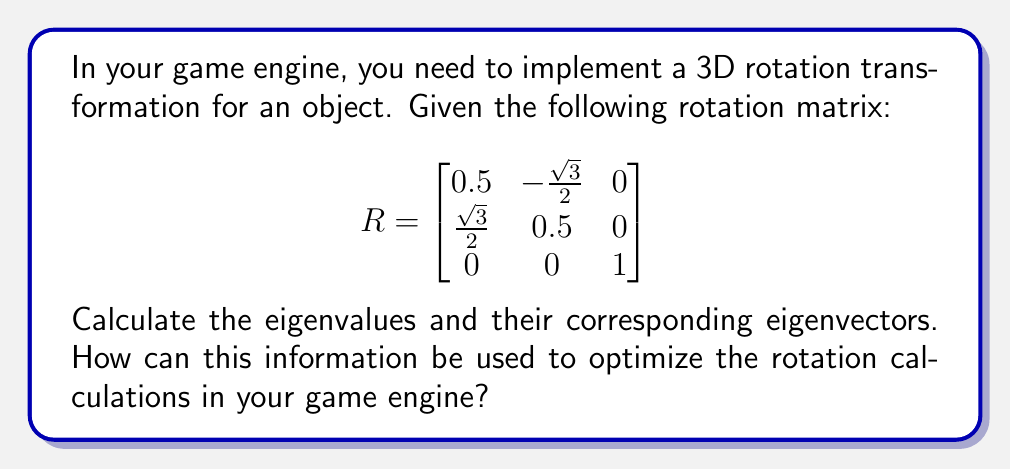Show me your answer to this math problem. To find the eigenvalues and eigenvectors, we follow these steps:

1. Calculate the characteristic polynomial:
   $$\det(R - \lambda I) = \begin{vmatrix}
   0.5 - \lambda & -\frac{\sqrt{3}}{2} & 0 \\
   \frac{\sqrt{3}}{2} & 0.5 - \lambda & 0 \\
   0 & 0 & 1 - \lambda
   \end{vmatrix}$$

2. Expand the determinant:
   $$(0.5 - \lambda)^2 + (\frac{\sqrt{3}}{2})^2 = (1 - \lambda)$$

3. Solve the characteristic equation:
   $$\lambda^2 - \lambda + 1 = 0$$

4. Find the eigenvalues:
   $$\lambda_1 = \frac{1 + i\sqrt{3}}{2}, \lambda_2 = \frac{1 - i\sqrt{3}}{2}, \lambda_3 = 1$$

5. For each eigenvalue, solve $(R - \lambda I)v = 0$ to find the eigenvectors:

   For $\lambda_1 = \frac{1 + i\sqrt{3}}{2}$:
   $$v_1 = \begin{bmatrix} 1 \\ i \\ 0 \end{bmatrix}$$

   For $\lambda_2 = \frac{1 - i\sqrt{3}}{2}$:
   $$v_2 = \begin{bmatrix} 1 \\ -i \\ 0 \end{bmatrix}$$

   For $\lambda_3 = 1$:
   $$v_3 = \begin{bmatrix} 0 \\ 0 \\ 1 \end{bmatrix}$$

Optimization: The eigenvalues and eigenvectors reveal that this rotation is a 60° rotation around the z-axis. The eigenvector $v_3$ corresponds to the axis of rotation. By recognizing this, you can optimize rotation calculations by:

1. Using a simplified rotation formula for rotations around the z-axis.
2. Caching pre-computed rotations for common angles.
3. Implementing quaternion-based rotations for smoother interpolations and to avoid gimbal lock.
Answer: Eigenvalues: $\lambda_1 = \frac{1 + i\sqrt{3}}{2}, \lambda_2 = \frac{1 - i\sqrt{3}}{2}, \lambda_3 = 1$
Eigenvectors: $v_1 = (1, i, 0), v_2 = (1, -i, 0), v_3 = (0, 0, 1)$
Optimization: Use z-axis rotation formula, cache common rotations, implement quaternions. 